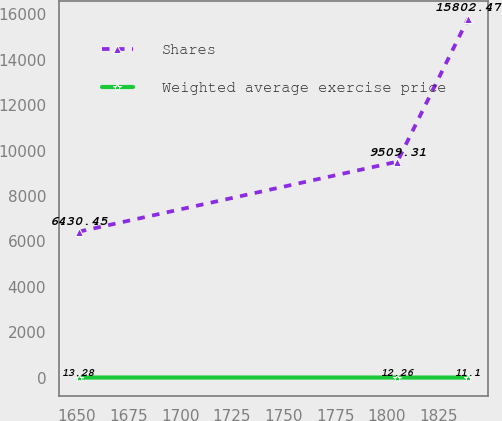Convert chart. <chart><loc_0><loc_0><loc_500><loc_500><line_chart><ecel><fcel>Shares<fcel>Weighted average exercise price<nl><fcel>1650.96<fcel>6430.45<fcel>13.28<nl><fcel>1804.98<fcel>9509.31<fcel>12.26<nl><fcel>1839.2<fcel>15802.5<fcel>11.1<nl></chart> 